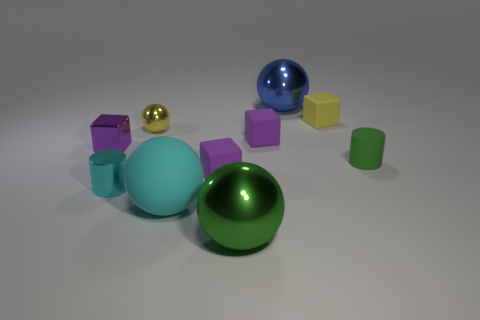What number of objects are either cyan metal cylinders or metal blocks?
Give a very brief answer. 2. There is a large metallic ball right of the big green metal sphere that is in front of the tiny yellow shiny thing; what number of yellow metallic spheres are to the right of it?
Offer a very short reply. 0. Is there anything else of the same color as the tiny matte cylinder?
Ensure brevity in your answer.  Yes. Is the color of the big metallic object that is in front of the tiny rubber cylinder the same as the large shiny ball behind the large matte object?
Provide a short and direct response. No. Is the number of tiny metal cubes left of the tiny green rubber cylinder greater than the number of cyan rubber spheres that are on the right side of the green sphere?
Provide a succinct answer. Yes. What material is the cyan cylinder?
Your answer should be very brief. Metal. There is a yellow thing right of the large thing behind the green thing behind the matte sphere; what is its shape?
Ensure brevity in your answer.  Cube. Is the ball on the right side of the large green shiny ball made of the same material as the purple block that is on the left side of the small metallic ball?
Ensure brevity in your answer.  Yes. What number of tiny cubes are both on the right side of the large matte object and on the left side of the big blue object?
Ensure brevity in your answer.  2. Is there a blue thing of the same shape as the big green thing?
Offer a terse response. Yes. 